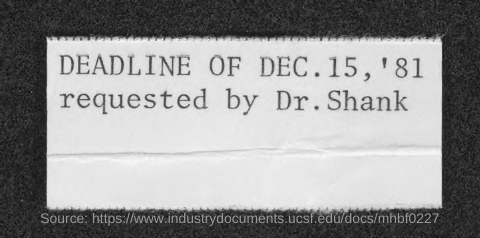Who requested deadline of dec. 15, '81?
Your answer should be compact. Dr. Shank. 